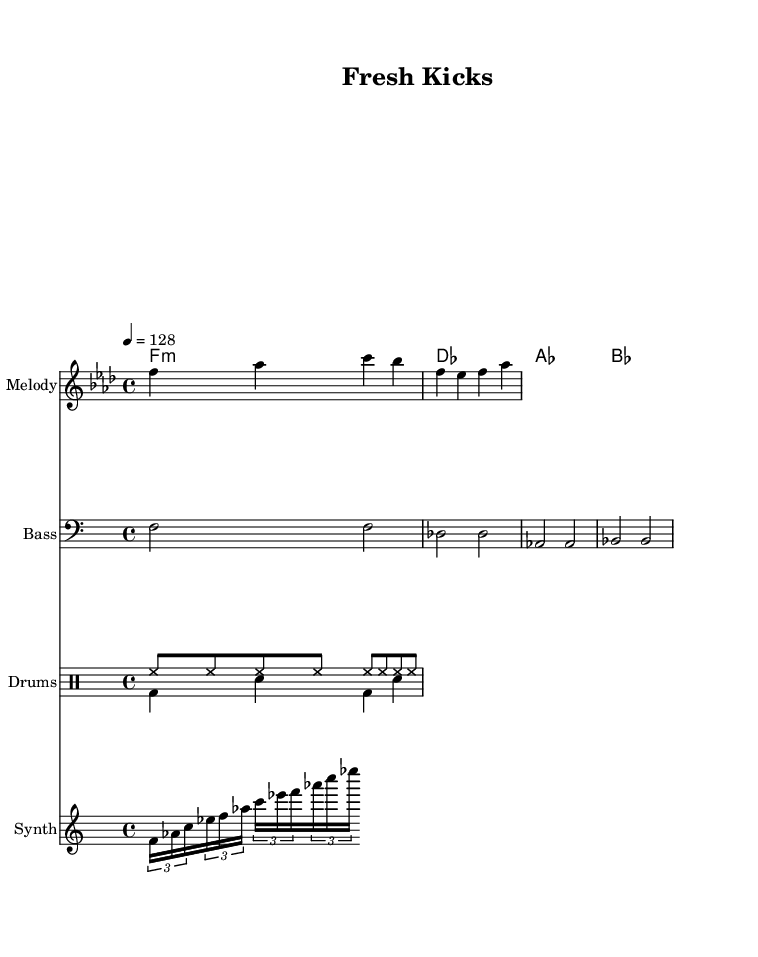What is the key signature of this music? The key signature is F minor, indicated by the presence of four flats in the key signature.
Answer: F minor What is the time signature of the piece? The time signature is 4/4, denoted by the "4/4" displayed at the beginning of the score.
Answer: 4/4 What is the tempo marking for the music? The tempo marking is given as "4 = 128," which indicates there are 128 beats per minute.
Answer: 128 How many measures are in the melody section? The melody is structured in 4 measures, as seen from the grouping of the notes. Each line of music typically represents a measure.
Answer: 4 What is the chord progression used in the harmonies? The chord progression consists of F minor, D flat, A flat, and B flat, which are notated sequentially in the chord mode.
Answer: F minor, D flat, A flat, B flat What lyrical theme is presented in the verse? The verse emphasizes streetwear fashion and urban culture, explicitly mentioning "fresh kicks" and "urban style."
Answer: Streetwear fashion and urban culture What is the main focus of the chorus lyrics? The chorus focuses on being a sneakerhead and staying ahead in fashion drops, encapsulating the search for the latest sneaker releases.
Answer: Sneakerhead and latest drops 